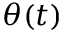Convert formula to latex. <formula><loc_0><loc_0><loc_500><loc_500>\theta ( t )</formula> 